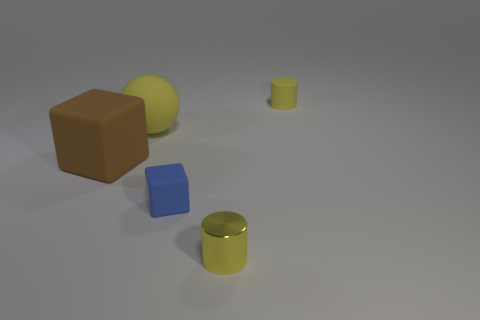Add 1 big rubber objects. How many objects exist? 6 Subtract all blocks. How many objects are left? 3 Add 4 shiny cylinders. How many shiny cylinders are left? 5 Add 2 yellow shiny things. How many yellow shiny things exist? 3 Subtract 0 brown spheres. How many objects are left? 5 Subtract all tiny yellow shiny objects. Subtract all yellow metallic objects. How many objects are left? 3 